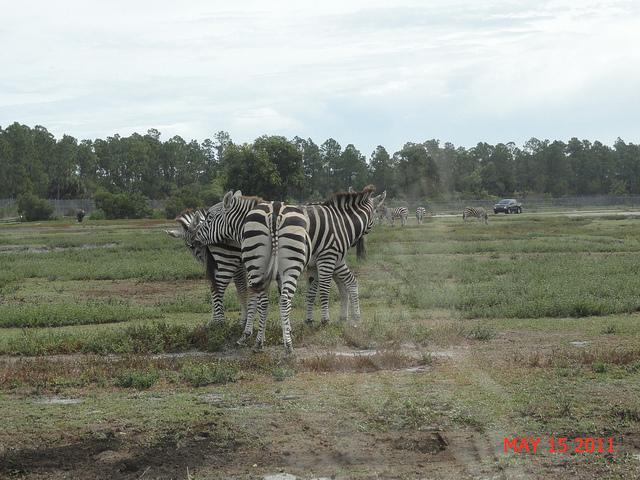What animal is most similar to these?

Choices:
A) horse
B) echidna
C) leopard
D) sugar glider horse 